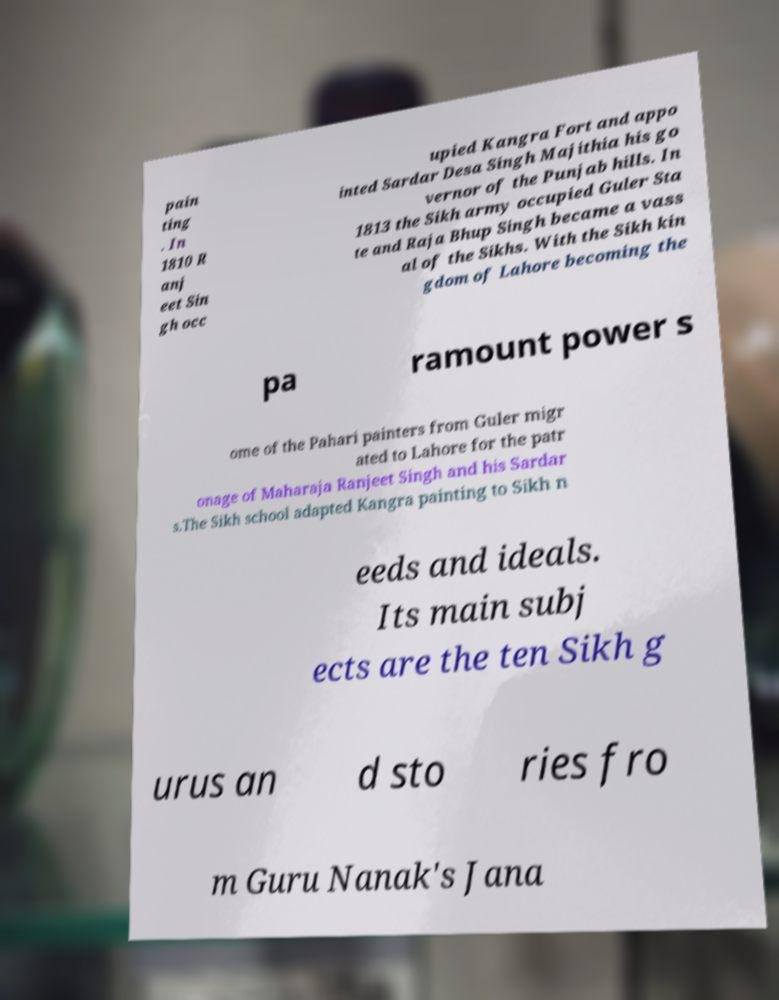Could you extract and type out the text from this image? pain ting . In 1810 R anj eet Sin gh occ upied Kangra Fort and appo inted Sardar Desa Singh Majithia his go vernor of the Punjab hills. In 1813 the Sikh army occupied Guler Sta te and Raja Bhup Singh became a vass al of the Sikhs. With the Sikh kin gdom of Lahore becoming the pa ramount power s ome of the Pahari painters from Guler migr ated to Lahore for the patr onage of Maharaja Ranjeet Singh and his Sardar s.The Sikh school adapted Kangra painting to Sikh n eeds and ideals. Its main subj ects are the ten Sikh g urus an d sto ries fro m Guru Nanak's Jana 